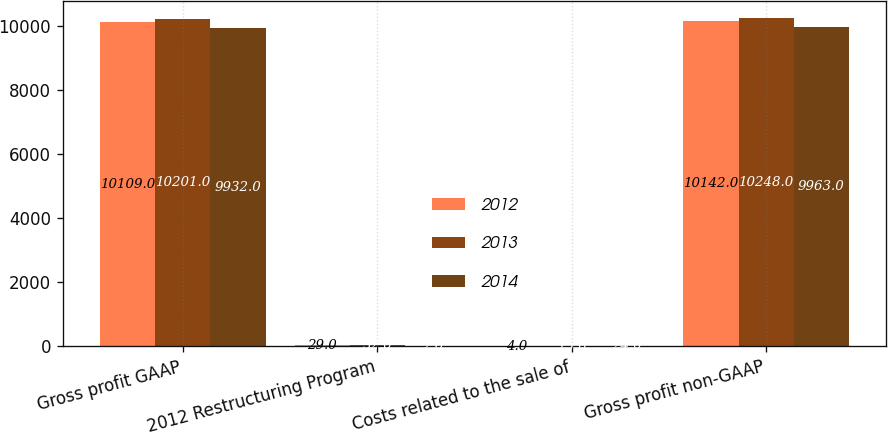Convert chart. <chart><loc_0><loc_0><loc_500><loc_500><stacked_bar_chart><ecel><fcel>Gross profit GAAP<fcel>2012 Restructuring Program<fcel>Costs related to the sale of<fcel>Gross profit non-GAAP<nl><fcel>2012<fcel>10109<fcel>29<fcel>4<fcel>10142<nl><fcel>2013<fcel>10201<fcel>32<fcel>15<fcel>10248<nl><fcel>2014<fcel>9932<fcel>2<fcel>24<fcel>9963<nl></chart> 